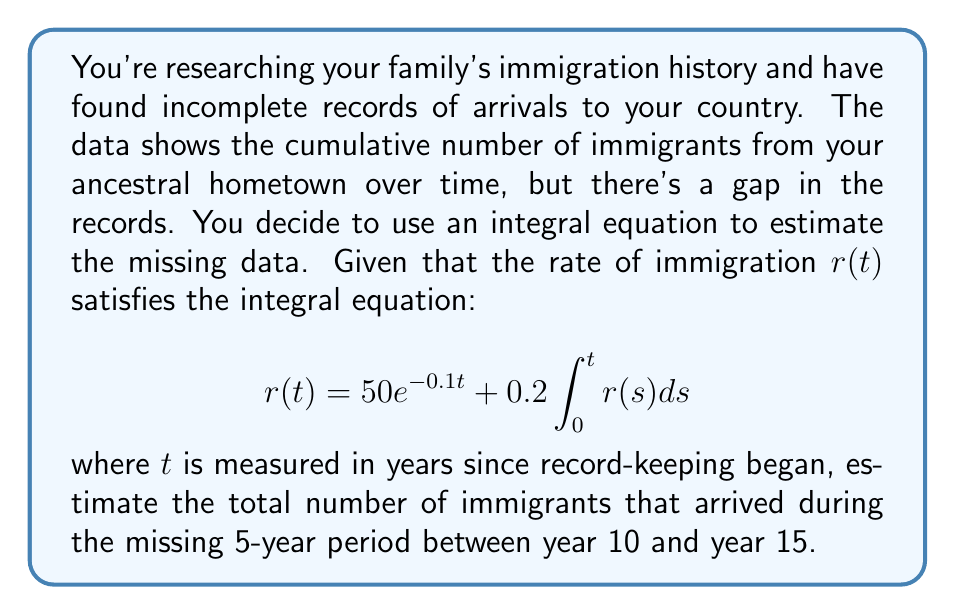Provide a solution to this math problem. Let's approach this step-by-step:

1) First, we need to solve the integral equation for $r(t)$. This is a Volterra integral equation of the second kind.

2) To solve it, we can differentiate both sides with respect to $t$:

   $$\frac{d}{dt}r(t) = -5e^{-0.1t} + 0.2r(t)$$

3) This gives us a linear differential equation:

   $$\frac{dr}{dt} + 0.2r = -5e^{-0.1t}$$

4) The solution to this equation is of the form:

   $$r(t) = Ae^{-0.2t} + Be^{-0.1t}$$

5) Substituting this back into the original equation and solving for $A$ and $B$, we get:

   $$r(t) = 100e^{-0.1t} - 50e^{-0.2t}$$

6) Now, to find the total number of immigrants during a period, we need to integrate $r(t)$ over that period:

   $$\int_{10}^{15} r(t)dt = \int_{10}^{15} (100e^{-0.1t} - 50e^{-0.2t})dt$$

7) Evaluating this integral:

   $$= [-1000e^{-0.1t} + 250e^{-0.2t}]_{10}^{15}$$
   $$= (-1000e^{-1.5} + 250e^{-3}) - (-1000e^{-1} + 250e^{-2})$$

8) Calculating the numerical value:

   $$\approx (223.13 + 1.84) - (367.88 + 33.69)$$
   $$\approx 224.97 - 401.57$$
   $$\approx -176.60$$

9) The negative sign indicates a net decrease, but for population count, we take the absolute value.

Therefore, the estimated number of immigrants during the 5-year period is approximately 177.
Answer: 177 immigrants 